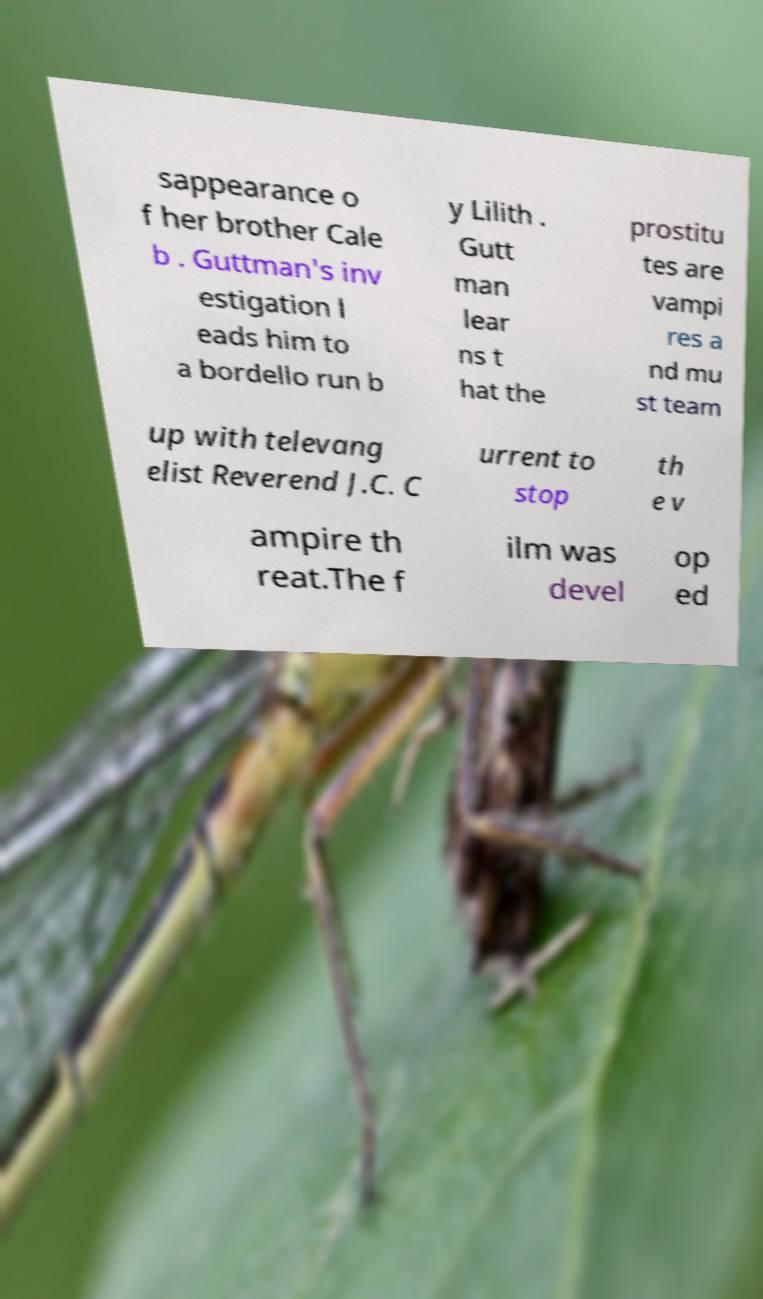There's text embedded in this image that I need extracted. Can you transcribe it verbatim? sappearance o f her brother Cale b . Guttman's inv estigation l eads him to a bordello run b y Lilith . Gutt man lear ns t hat the prostitu tes are vampi res a nd mu st team up with televang elist Reverend J.C. C urrent to stop th e v ampire th reat.The f ilm was devel op ed 